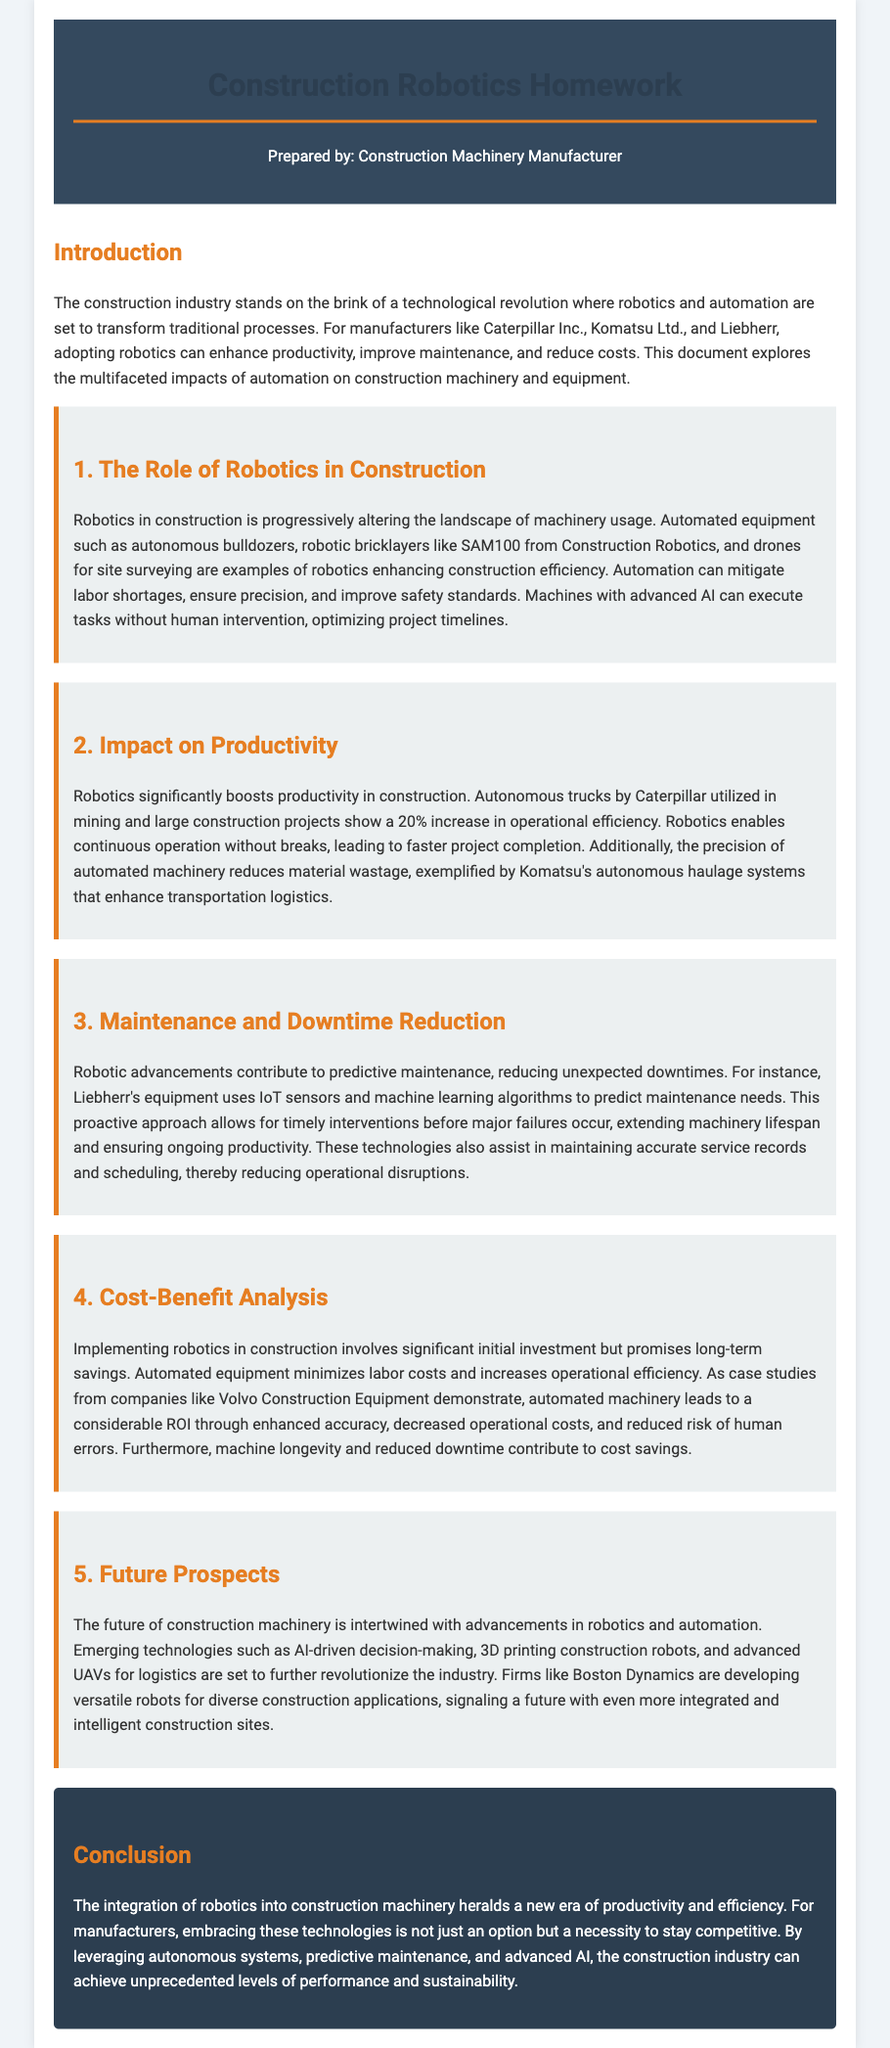What is the title of the document? The title of the document is presented in the heading as 'Construction Robotics Homework'.
Answer: Construction Robotics Homework Who prepared the document? The preparer is mentioned in the header section, stating 'Prepared by: Construction Machinery Manufacturer'.
Answer: Construction Machinery Manufacturer What is the percentage increase in operational efficiency due to robotics? The document states that autonomous trucks show a 20% increase in operational efficiency.
Answer: 20% What technology does Liebherr's equipment use for predictive maintenance? The document specifies that Liebherr uses IoT sensors and machine learning algorithms for predictive maintenance.
Answer: IoT sensors and machine learning algorithms What is a key future technology mentioned for construction? A key future technology noted in the document is 3D printing construction robots.
Answer: 3D printing construction robots What role does automation play in addressing labor shortages? The document indicates that automation can mitigate labor shortages in the construction industry.
Answer: Mitigate labor shortages What type of maintenance approach is highlighted in the document? It mentions a proactive maintenance approach resulting from robotic advancements.
Answer: Predictive maintenance How does robotics contribute to material usage? The document states that the precision of automated machinery reduces material wastage.
Answer: Reduces material wastage What is a significant benefit of automated equipment mentioned in the conclusion? The conclusion emphasizes that embracing robotics is a necessity to stay competitive.
Answer: Necessity to stay competitive 